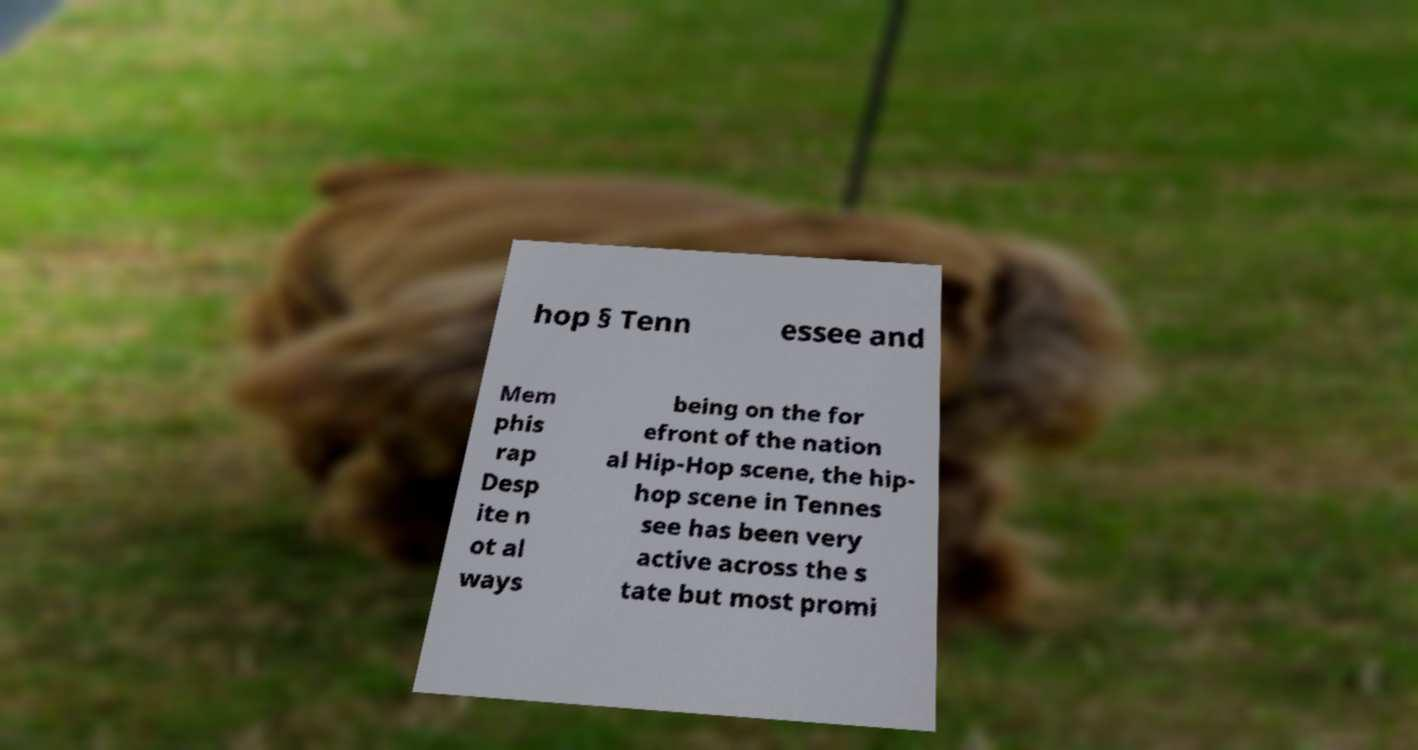Please identify and transcribe the text found in this image. hop § Tenn essee and Mem phis rap Desp ite n ot al ways being on the for efront of the nation al Hip-Hop scene, the hip- hop scene in Tennes see has been very active across the s tate but most promi 